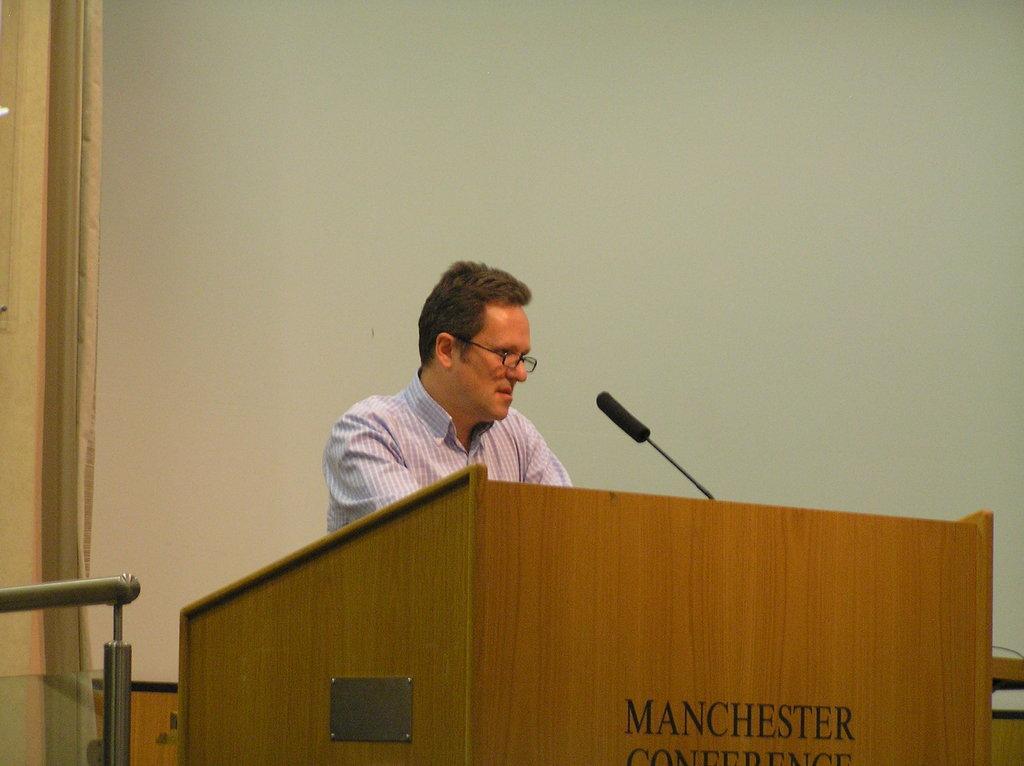Could you give a brief overview of what you see in this image? In this image I can see a person behind the brown colored podium. On the podium I can see the microphone. I can see the white and cream colored background. 